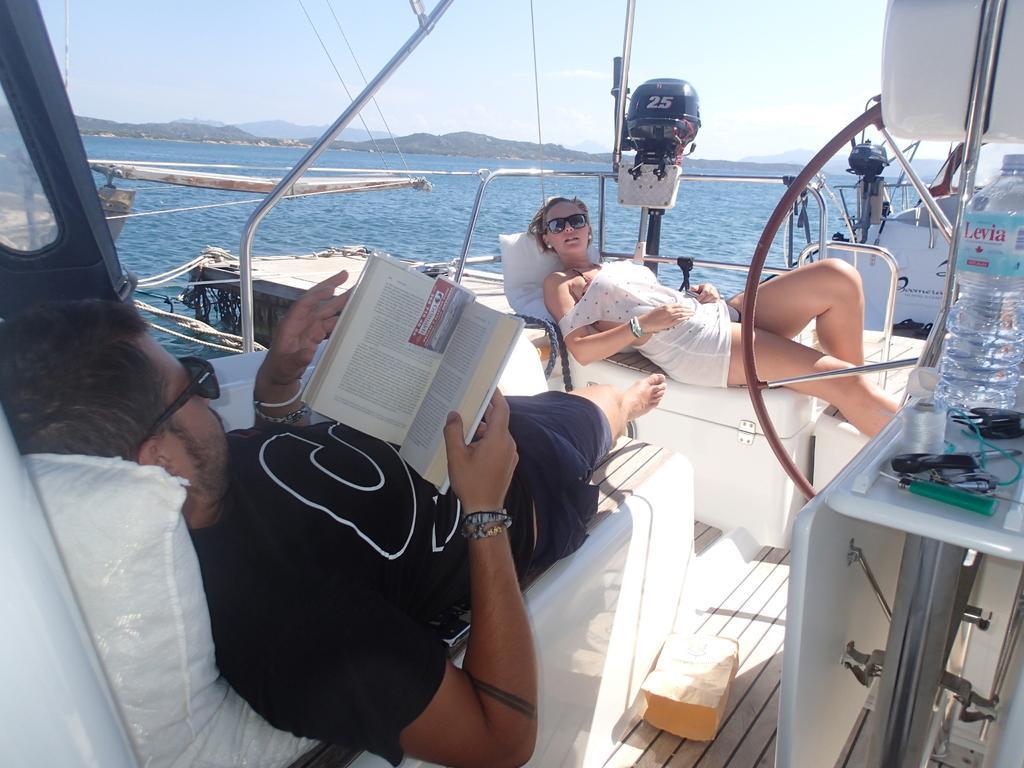How would you summarize this image in a sentence or two? In this image we can see two persons in the ship. Here we can see a man on the left side and he is reading a book. Here we can see a woman. Here we can see the water bottle on the right side. In the background, we can see the ocean. This is a sky with clouds. 